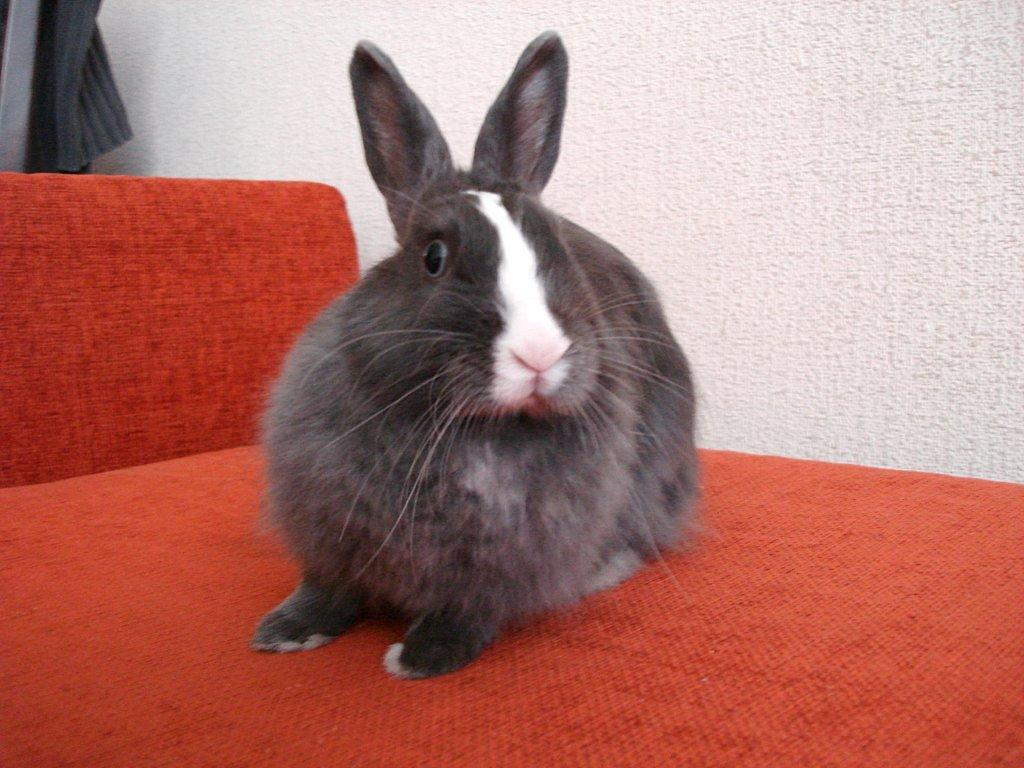What type of furniture is in the image? There is a red couch in the image. What is located above the red couch? There is a rabbit above the red couch. What color is the wall in the background of the image? There is a white wall in the background of the image. What type of material is present in the background of the image? There is a woolen cloth in the background of the image. What type of toothpaste is being used in the image? There is no toothpaste present in the image. Is there a hospital visible in the image? There is no hospital present in the image. 